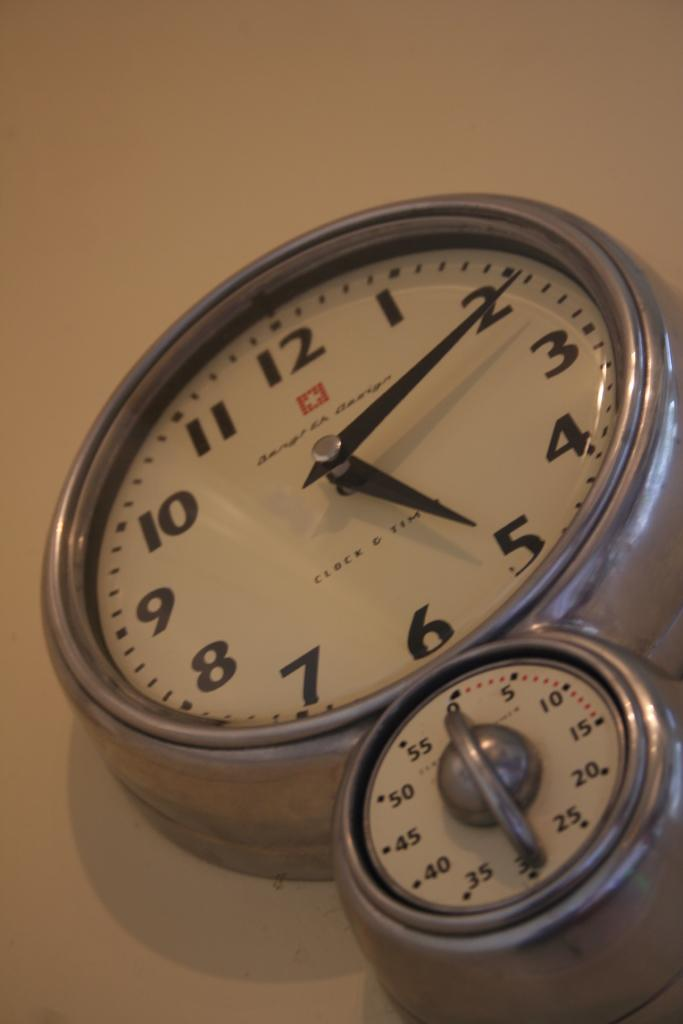<image>
Write a terse but informative summary of the picture. A wall clock that indicates the time as 5:11 and a timer sits underneath the clock. 